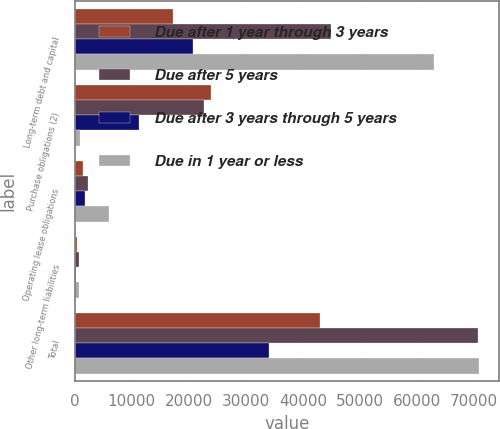<chart> <loc_0><loc_0><loc_500><loc_500><stacked_bar_chart><ecel><fcel>Long-term debt and capital<fcel>Purchase obligations (2)<fcel>Operating lease obligations<fcel>Other long-term liabilities<fcel>Total<nl><fcel>Due after 1 year through 3 years<fcel>17194<fcel>23918<fcel>1375<fcel>464<fcel>42951<nl><fcel>Due after 5 years<fcel>44962<fcel>22578<fcel>2410<fcel>676<fcel>70626<nl><fcel>Due after 3 years through 5 years<fcel>20799<fcel>11234<fcel>1732<fcel>290<fcel>34055<nl><fcel>Due in 1 year or less<fcel>63045<fcel>1005<fcel>5951<fcel>835<fcel>70836<nl></chart> 